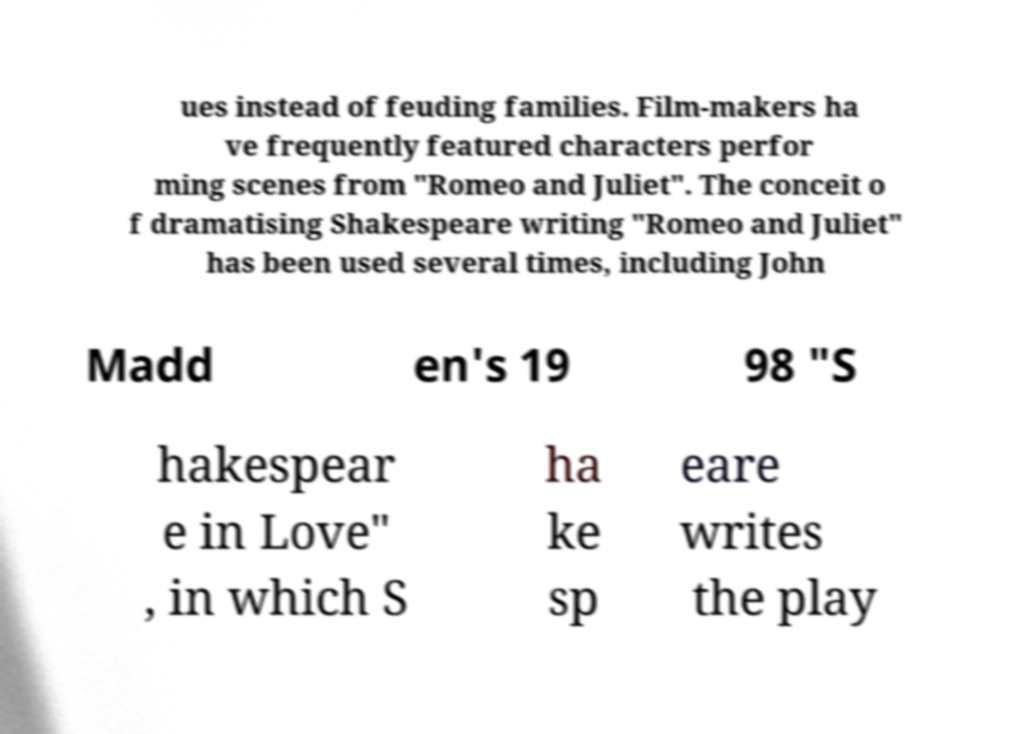What messages or text are displayed in this image? I need them in a readable, typed format. ues instead of feuding families. Film-makers ha ve frequently featured characters perfor ming scenes from "Romeo and Juliet". The conceit o f dramatising Shakespeare writing "Romeo and Juliet" has been used several times, including John Madd en's 19 98 "S hakespear e in Love" , in which S ha ke sp eare writes the play 